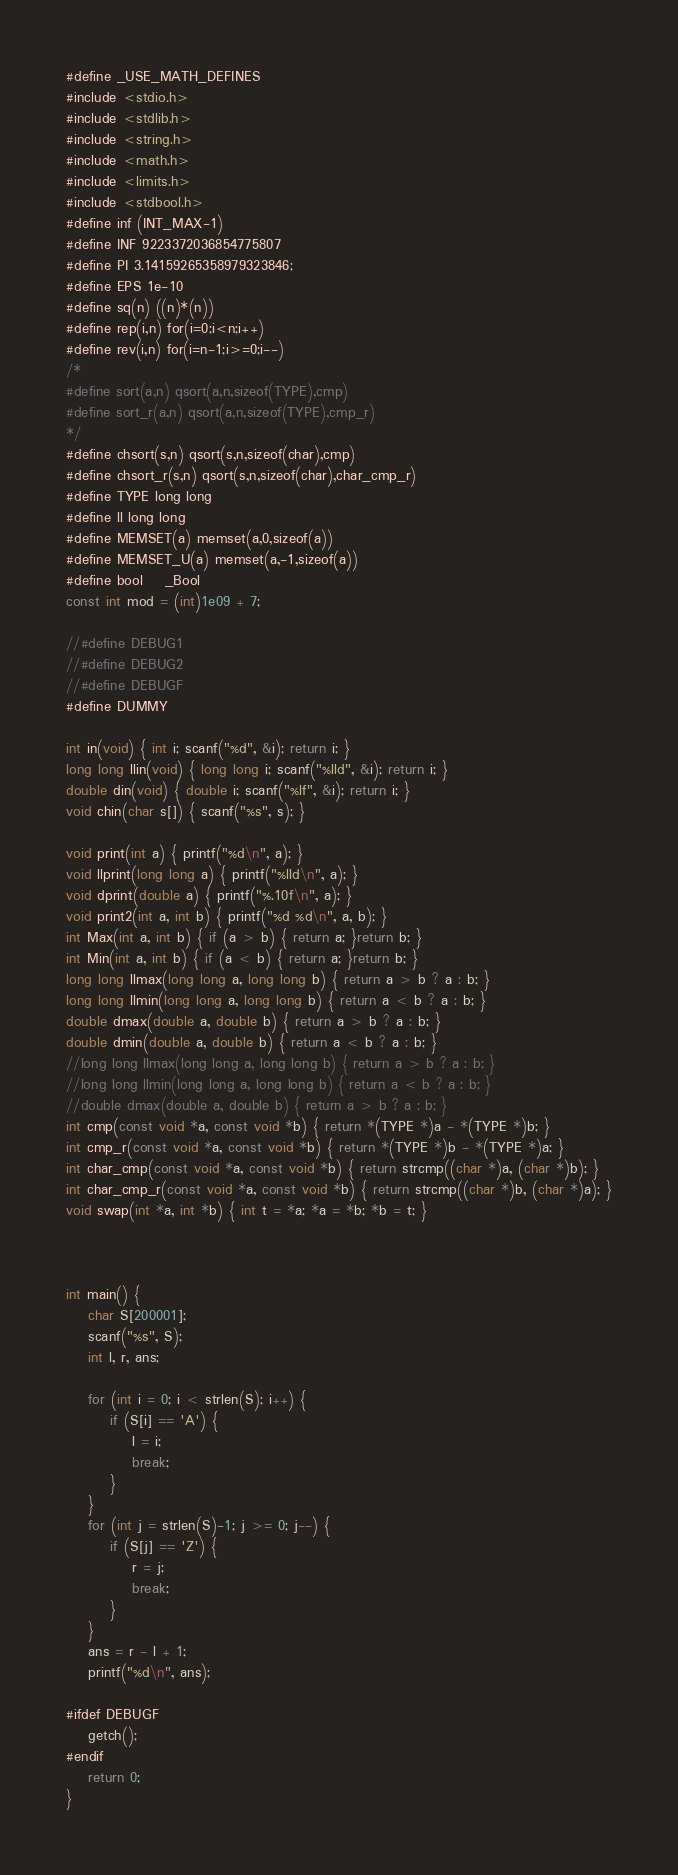<code> <loc_0><loc_0><loc_500><loc_500><_C_>
#define _USE_MATH_DEFINES
#include <stdio.h>
#include <stdlib.h>
#include <string.h>
#include <math.h>
#include <limits.h>  
#include <stdbool.h>   
#define inf (INT_MAX-1)
#define INF 9223372036854775807
#define PI 3.14159265358979323846;
#define EPS 1e-10
#define sq(n) ((n)*(n))
#define rep(i,n) for(i=0;i<n;i++)
#define rev(i,n) for(i=n-1;i>=0;i--)
/*
#define sort(a,n) qsort(a,n,sizeof(TYPE),cmp)
#define sort_r(a,n) qsort(a,n,sizeof(TYPE),cmp_r)
*/
#define chsort(s,n) qsort(s,n,sizeof(char),cmp)
#define chsort_r(s,n) qsort(s,n,sizeof(char),char_cmp_r)
#define TYPE long long
#define ll long long
#define MEMSET(a) memset(a,0,sizeof(a))
#define MEMSET_U(a) memset(a,-1,sizeof(a))
#define bool    _Bool
const int mod = (int)1e09 + 7;

//#define DEBUG1
//#define DEBUG2
//#define DEBUGF
#define DUMMY

int in(void) { int i; scanf("%d", &i); return i; }
long long llin(void) { long long i; scanf("%lld", &i); return i; }
double din(void) { double i; scanf("%lf", &i); return i; }
void chin(char s[]) { scanf("%s", s); }

void print(int a) { printf("%d\n", a); }
void llprint(long long a) { printf("%lld\n", a); }
void dprint(double a) { printf("%.10f\n", a); }
void print2(int a, int b) { printf("%d %d\n", a, b); }
int Max(int a, int b) { if (a > b) { return a; }return b; }
int Min(int a, int b) { if (a < b) { return a; }return b; }
long long llmax(long long a, long long b) { return a > b ? a : b; }
long long llmin(long long a, long long b) { return a < b ? a : b; }
double dmax(double a, double b) { return a > b ? a : b; }
double dmin(double a, double b) { return a < b ? a : b; }
//long long llmax(long long a, long long b) { return a > b ? a : b; }
//long long llmin(long long a, long long b) { return a < b ? a : b; }
//double dmax(double a, double b) { return a > b ? a : b; }
int cmp(const void *a, const void *b) { return *(TYPE *)a - *(TYPE *)b; }
int cmp_r(const void *a, const void *b) { return *(TYPE *)b - *(TYPE *)a; }
int char_cmp(const void *a, const void *b) { return strcmp((char *)a, (char *)b); }
int char_cmp_r(const void *a, const void *b) { return strcmp((char *)b, (char *)a); }
void swap(int *a, int *b) { int t = *a; *a = *b; *b = t; }



int main() {
	char S[200001];
	scanf("%s", S);
	int l, r, ans;

	for (int i = 0; i < strlen(S); i++) {
		if (S[i] == 'A') {
			l = i;
			break;
		}
	}
	for (int j = strlen(S)-1; j >= 0; j--) {
		if (S[j] == 'Z') {
			r = j;
			break;
		}
	}
	ans = r - l + 1;
	printf("%d\n", ans);

#ifdef DEBUGF
	getch();
#endif
	return 0;
}</code> 